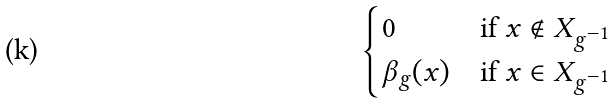<formula> <loc_0><loc_0><loc_500><loc_500>\begin{cases} 0 & \text {if } x \notin X _ { g ^ { - 1 } } \\ \beta _ { g } ( x ) & \text {if } x \in X _ { g ^ { - 1 } } \end{cases}</formula> 